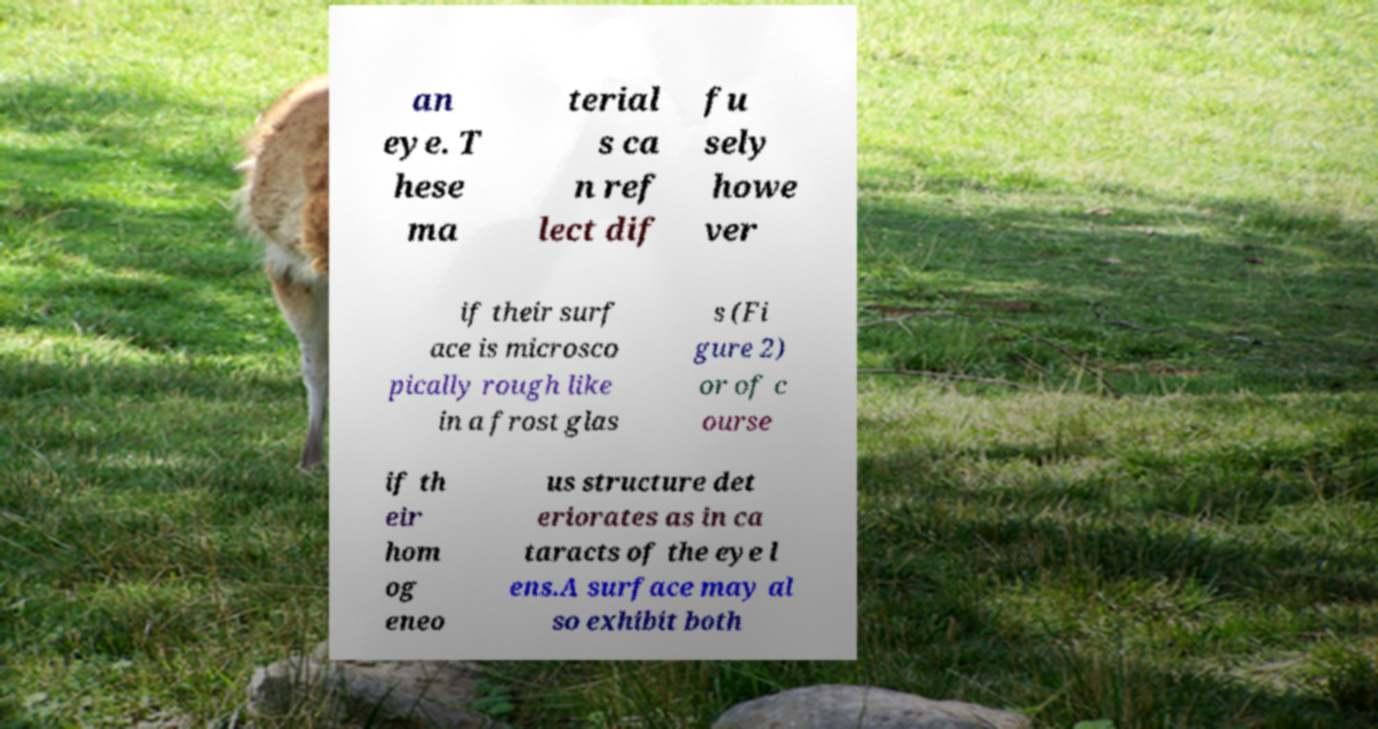I need the written content from this picture converted into text. Can you do that? an eye. T hese ma terial s ca n ref lect dif fu sely howe ver if their surf ace is microsco pically rough like in a frost glas s (Fi gure 2) or of c ourse if th eir hom og eneo us structure det eriorates as in ca taracts of the eye l ens.A surface may al so exhibit both 